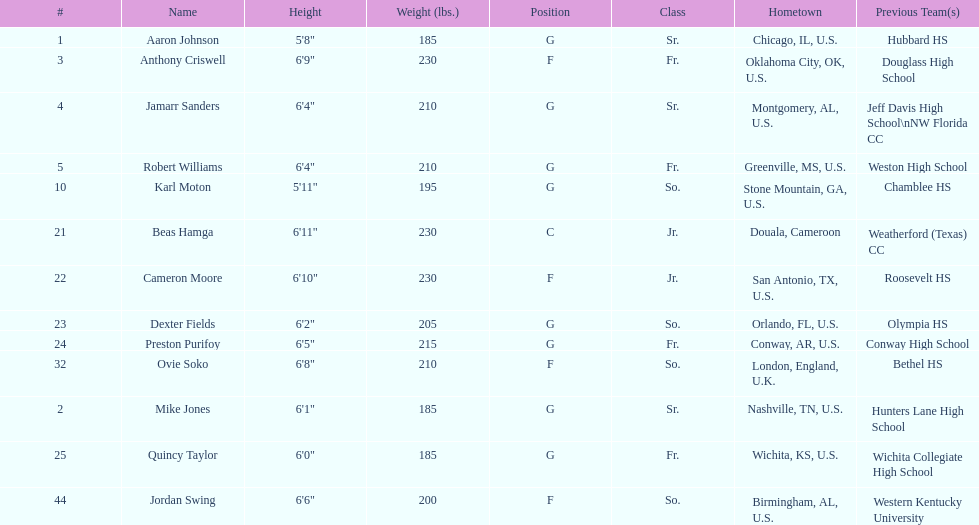Could you parse the entire table? {'header': ['#', 'Name', 'Height', 'Weight (lbs.)', 'Position', 'Class', 'Hometown', 'Previous Team(s)'], 'rows': [['1', 'Aaron Johnson', '5\'8"', '185', 'G', 'Sr.', 'Chicago, IL, U.S.', 'Hubbard HS'], ['3', 'Anthony Criswell', '6\'9"', '230', 'F', 'Fr.', 'Oklahoma City, OK, U.S.', 'Douglass High School'], ['4', 'Jamarr Sanders', '6\'4"', '210', 'G', 'Sr.', 'Montgomery, AL, U.S.', 'Jeff Davis High School\\nNW Florida CC'], ['5', 'Robert Williams', '6\'4"', '210', 'G', 'Fr.', 'Greenville, MS, U.S.', 'Weston High School'], ['10', 'Karl Moton', '5\'11"', '195', 'G', 'So.', 'Stone Mountain, GA, U.S.', 'Chamblee HS'], ['21', 'Beas Hamga', '6\'11"', '230', 'C', 'Jr.', 'Douala, Cameroon', 'Weatherford (Texas) CC'], ['22', 'Cameron Moore', '6\'10"', '230', 'F', 'Jr.', 'San Antonio, TX, U.S.', 'Roosevelt HS'], ['23', 'Dexter Fields', '6\'2"', '205', 'G', 'So.', 'Orlando, FL, U.S.', 'Olympia HS'], ['24', 'Preston Purifoy', '6\'5"', '215', 'G', 'Fr.', 'Conway, AR, U.S.', 'Conway High School'], ['32', 'Ovie Soko', '6\'8"', '210', 'F', 'So.', 'London, England, U.K.', 'Bethel HS'], ['2', 'Mike Jones', '6\'1"', '185', 'G', 'Sr.', 'Nashville, TN, U.S.', 'Hunters Lane High School'], ['25', 'Quincy Taylor', '6\'0"', '185', 'G', 'Fr.', 'Wichita, KS, U.S.', 'Wichita Collegiate High School'], ['44', 'Jordan Swing', '6\'6"', '200', 'F', 'So.', 'Birmingham, AL, U.S.', 'Western Kentucky University']]} Who is the tallest player on the team? Beas Hamga. 